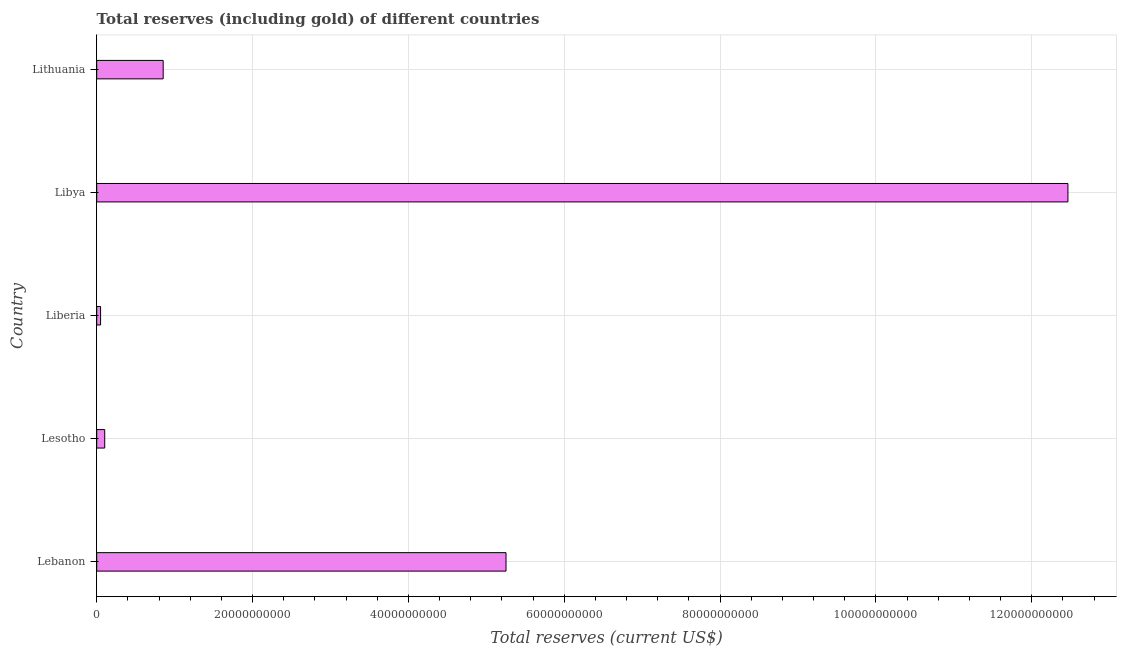Does the graph contain any zero values?
Your response must be concise. No. Does the graph contain grids?
Provide a succinct answer. Yes. What is the title of the graph?
Offer a very short reply. Total reserves (including gold) of different countries. What is the label or title of the X-axis?
Make the answer very short. Total reserves (current US$). What is the total reserves (including gold) in Lithuania?
Keep it short and to the point. 8.53e+09. Across all countries, what is the maximum total reserves (including gold)?
Provide a short and direct response. 1.25e+11. Across all countries, what is the minimum total reserves (including gold)?
Offer a terse response. 4.97e+08. In which country was the total reserves (including gold) maximum?
Offer a terse response. Libya. In which country was the total reserves (including gold) minimum?
Make the answer very short. Liberia. What is the sum of the total reserves (including gold)?
Your response must be concise. 1.87e+11. What is the difference between the total reserves (including gold) in Lebanon and Liberia?
Your answer should be compact. 5.20e+1. What is the average total reserves (including gold) per country?
Provide a succinct answer. 3.74e+1. What is the median total reserves (including gold)?
Make the answer very short. 8.53e+09. In how many countries, is the total reserves (including gold) greater than 100000000000 US$?
Give a very brief answer. 1. What is the ratio of the total reserves (including gold) in Lebanon to that in Liberia?
Offer a very short reply. 105.65. Is the total reserves (including gold) in Lebanon less than that in Lithuania?
Provide a short and direct response. No. What is the difference between the highest and the second highest total reserves (including gold)?
Your answer should be compact. 7.21e+1. What is the difference between the highest and the lowest total reserves (including gold)?
Keep it short and to the point. 1.24e+11. In how many countries, is the total reserves (including gold) greater than the average total reserves (including gold) taken over all countries?
Keep it short and to the point. 2. Are all the bars in the graph horizontal?
Your response must be concise. Yes. What is the difference between two consecutive major ticks on the X-axis?
Provide a succinct answer. 2.00e+1. What is the Total reserves (current US$) in Lebanon?
Offer a terse response. 5.25e+1. What is the Total reserves (current US$) in Lesotho?
Your response must be concise. 1.03e+09. What is the Total reserves (current US$) of Liberia?
Keep it short and to the point. 4.97e+08. What is the Total reserves (current US$) of Libya?
Give a very brief answer. 1.25e+11. What is the Total reserves (current US$) of Lithuania?
Offer a terse response. 8.53e+09. What is the difference between the Total reserves (current US$) in Lebanon and Lesotho?
Offer a very short reply. 5.15e+1. What is the difference between the Total reserves (current US$) in Lebanon and Liberia?
Ensure brevity in your answer.  5.20e+1. What is the difference between the Total reserves (current US$) in Lebanon and Libya?
Provide a succinct answer. -7.21e+1. What is the difference between the Total reserves (current US$) in Lebanon and Lithuania?
Keep it short and to the point. 4.40e+1. What is the difference between the Total reserves (current US$) in Lesotho and Liberia?
Your answer should be very brief. 5.31e+08. What is the difference between the Total reserves (current US$) in Lesotho and Libya?
Give a very brief answer. -1.24e+11. What is the difference between the Total reserves (current US$) in Lesotho and Lithuania?
Offer a very short reply. -7.50e+09. What is the difference between the Total reserves (current US$) in Liberia and Libya?
Offer a very short reply. -1.24e+11. What is the difference between the Total reserves (current US$) in Liberia and Lithuania?
Your answer should be compact. -8.03e+09. What is the difference between the Total reserves (current US$) in Libya and Lithuania?
Keep it short and to the point. 1.16e+11. What is the ratio of the Total reserves (current US$) in Lebanon to that in Lesotho?
Ensure brevity in your answer.  51.1. What is the ratio of the Total reserves (current US$) in Lebanon to that in Liberia?
Your response must be concise. 105.65. What is the ratio of the Total reserves (current US$) in Lebanon to that in Libya?
Ensure brevity in your answer.  0.42. What is the ratio of the Total reserves (current US$) in Lebanon to that in Lithuania?
Provide a short and direct response. 6.16. What is the ratio of the Total reserves (current US$) in Lesotho to that in Liberia?
Offer a very short reply. 2.07. What is the ratio of the Total reserves (current US$) in Lesotho to that in Libya?
Your answer should be very brief. 0.01. What is the ratio of the Total reserves (current US$) in Lesotho to that in Lithuania?
Your answer should be very brief. 0.12. What is the ratio of the Total reserves (current US$) in Liberia to that in Libya?
Provide a short and direct response. 0. What is the ratio of the Total reserves (current US$) in Liberia to that in Lithuania?
Your answer should be very brief. 0.06. What is the ratio of the Total reserves (current US$) in Libya to that in Lithuania?
Make the answer very short. 14.61. 